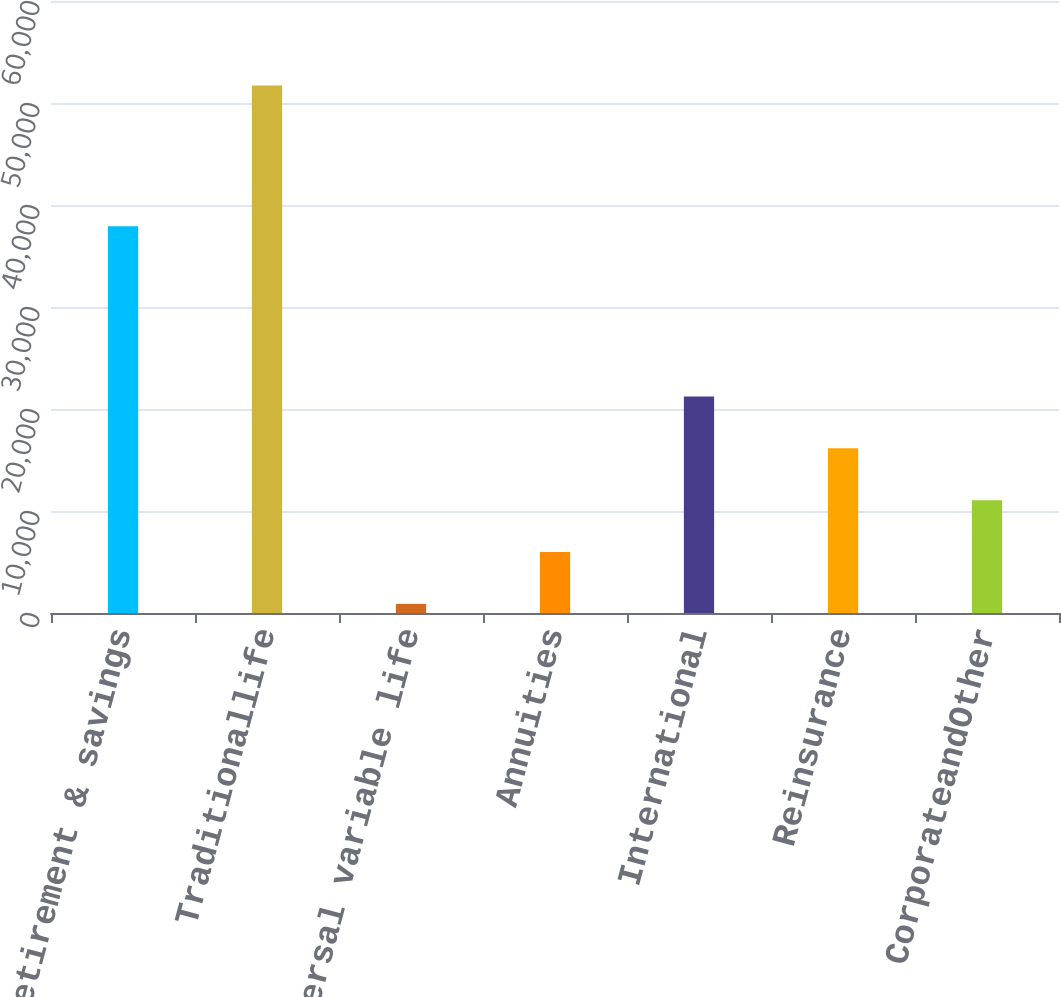Convert chart. <chart><loc_0><loc_0><loc_500><loc_500><bar_chart><fcel>Retirement & savings<fcel>Traditionallife<fcel>Universal variable life<fcel>Annuities<fcel>International<fcel>Reinsurance<fcel>CorporateandOther<nl><fcel>37908<fcel>51715<fcel>894<fcel>5976.1<fcel>21222.4<fcel>16140.3<fcel>11058.2<nl></chart> 